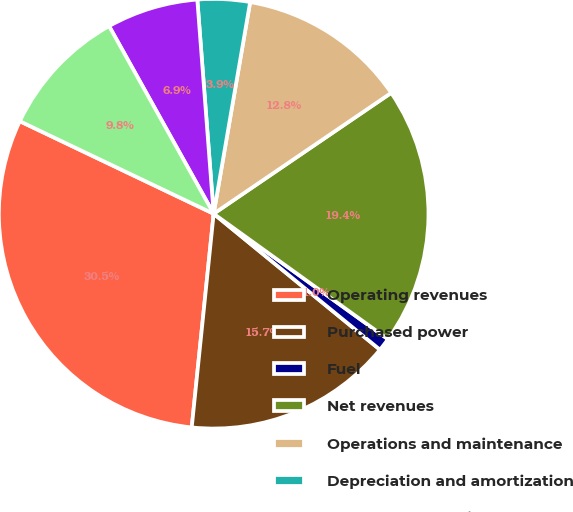<chart> <loc_0><loc_0><loc_500><loc_500><pie_chart><fcel>Operating revenues<fcel>Purchased power<fcel>Fuel<fcel>Net revenues<fcel>Operations and maintenance<fcel>Depreciation and amortization<fcel>Taxes other than income taxes<fcel>Electric operating income<nl><fcel>30.46%<fcel>15.72%<fcel>0.98%<fcel>19.44%<fcel>12.77%<fcel>3.93%<fcel>6.88%<fcel>9.82%<nl></chart> 